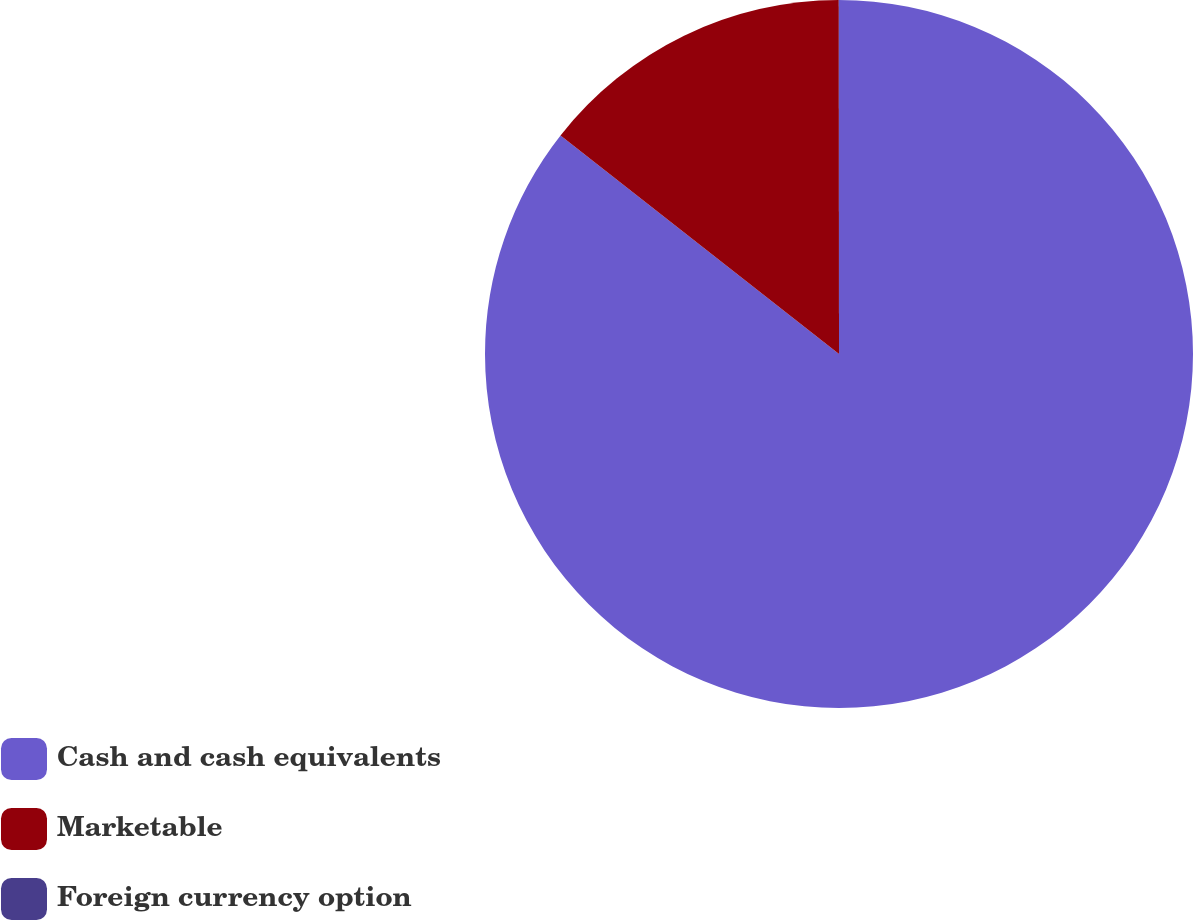Convert chart. <chart><loc_0><loc_0><loc_500><loc_500><pie_chart><fcel>Cash and cash equivalents<fcel>Marketable<fcel>Foreign currency option<nl><fcel>85.59%<fcel>14.4%<fcel>0.01%<nl></chart> 